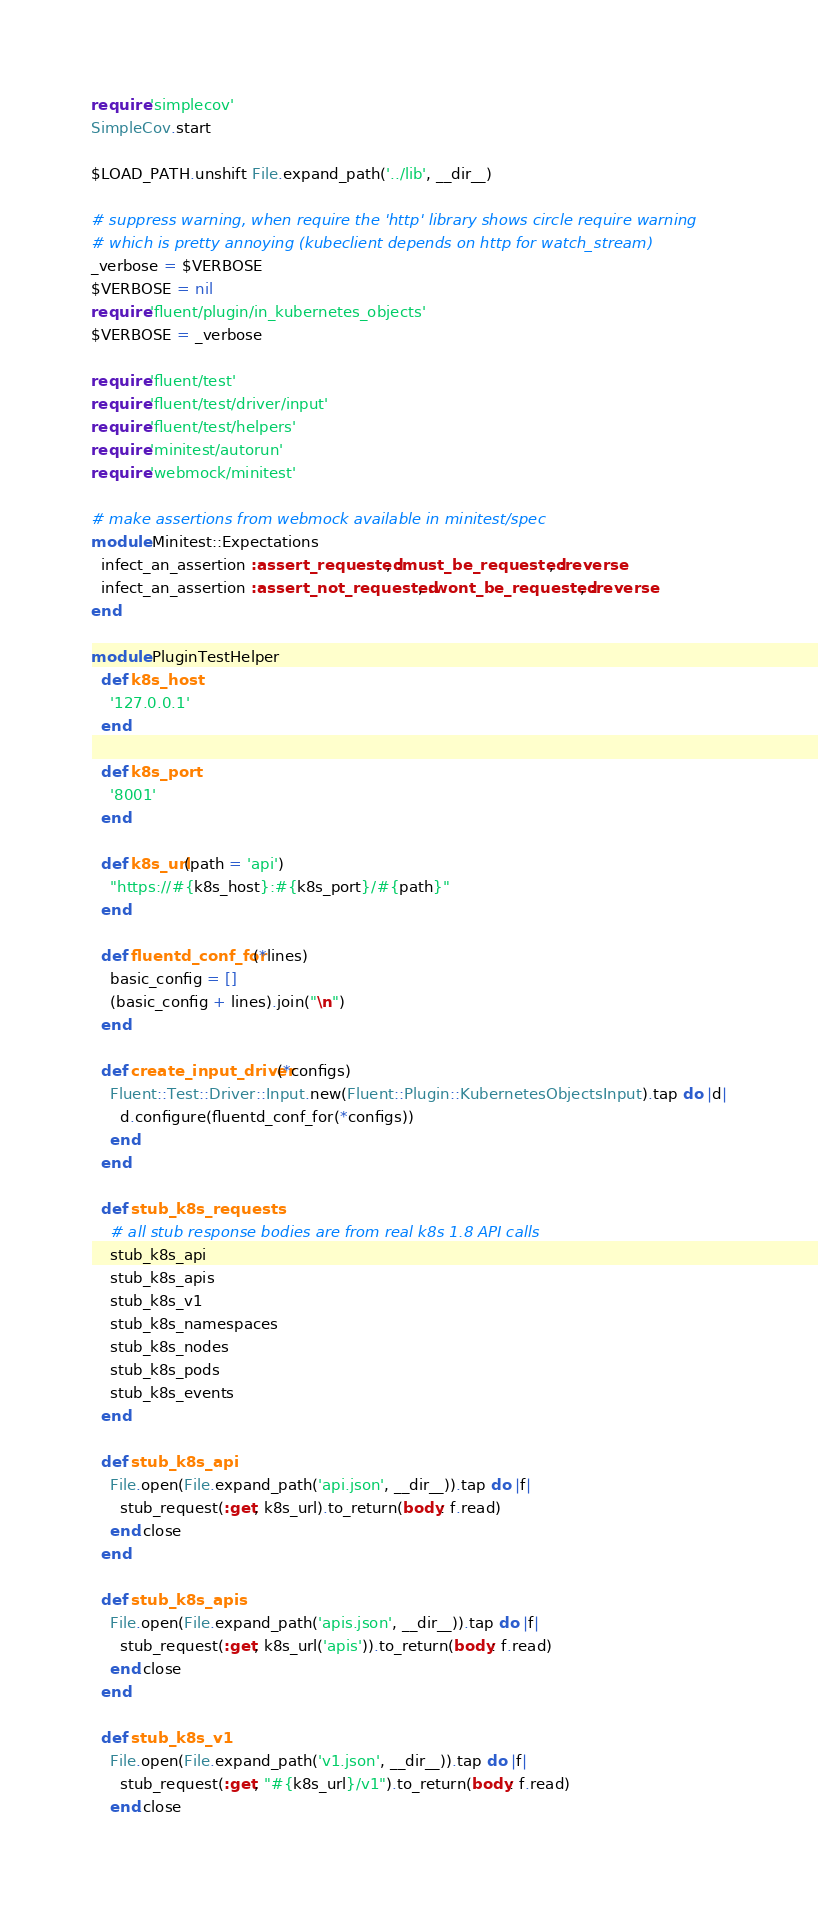Convert code to text. <code><loc_0><loc_0><loc_500><loc_500><_Ruby_>require 'simplecov'
SimpleCov.start

$LOAD_PATH.unshift File.expand_path('../lib', __dir__)

# suppress warning, when require the 'http' library shows circle require warning
# which is pretty annoying (kubeclient depends on http for watch_stream)
_verbose = $VERBOSE
$VERBOSE = nil
require 'fluent/plugin/in_kubernetes_objects'
$VERBOSE = _verbose

require 'fluent/test'
require 'fluent/test/driver/input'
require 'fluent/test/helpers'
require 'minitest/autorun'
require 'webmock/minitest'

# make assertions from webmock available in minitest/spec
module Minitest::Expectations
  infect_an_assertion :assert_requested, :must_be_requested, :reverse
  infect_an_assertion :assert_not_requested, :wont_be_requested, :reverse
end

module PluginTestHelper
  def k8s_host
    '127.0.0.1'
  end

  def k8s_port
    '8001'
  end

  def k8s_url(path = 'api')
    "https://#{k8s_host}:#{k8s_port}/#{path}"
  end

  def fluentd_conf_for(*lines)
    basic_config = []
    (basic_config + lines).join("\n")
  end

  def create_input_driver(*configs)
    Fluent::Test::Driver::Input.new(Fluent::Plugin::KubernetesObjectsInput).tap do |d|
      d.configure(fluentd_conf_for(*configs))
    end
  end

  def stub_k8s_requests
    # all stub response bodies are from real k8s 1.8 API calls
    stub_k8s_api
    stub_k8s_apis
    stub_k8s_v1
    stub_k8s_namespaces
    stub_k8s_nodes
    stub_k8s_pods
    stub_k8s_events
  end

  def stub_k8s_api
    File.open(File.expand_path('api.json', __dir__)).tap do |f|
      stub_request(:get, k8s_url).to_return(body: f.read)
    end.close
  end

  def stub_k8s_apis
    File.open(File.expand_path('apis.json', __dir__)).tap do |f|
      stub_request(:get, k8s_url('apis')).to_return(body: f.read)
    end.close
  end

  def stub_k8s_v1
    File.open(File.expand_path('v1.json', __dir__)).tap do |f|
      stub_request(:get, "#{k8s_url}/v1").to_return(body: f.read)
    end.close</code> 